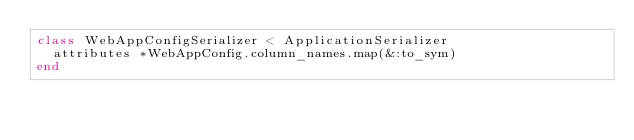Convert code to text. <code><loc_0><loc_0><loc_500><loc_500><_Ruby_>class WebAppConfigSerializer < ApplicationSerializer
  attributes *WebAppConfig.column_names.map(&:to_sym)
end
</code> 